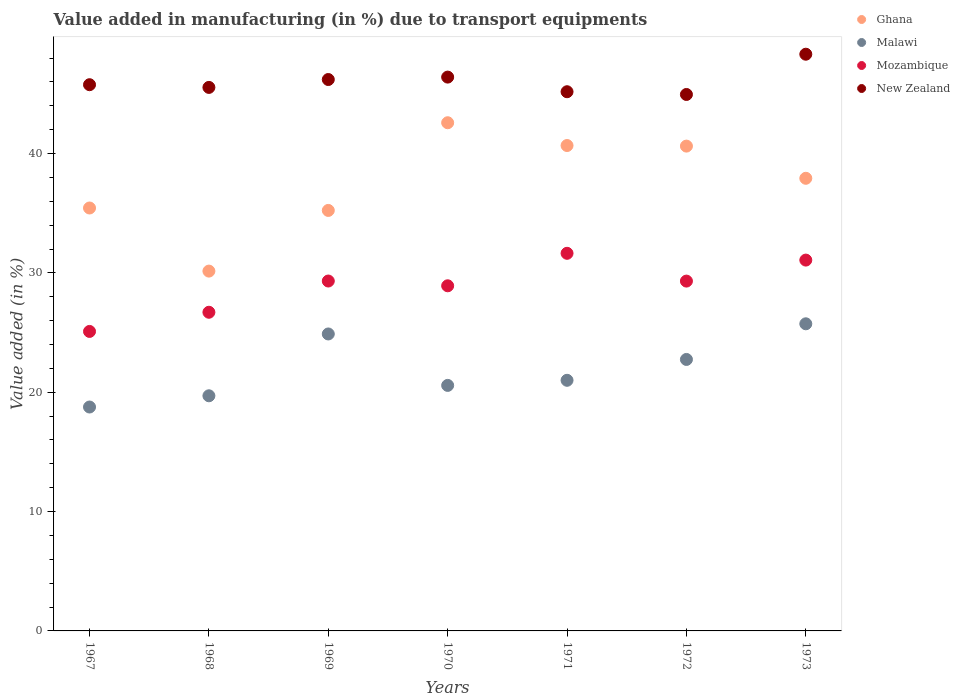How many different coloured dotlines are there?
Provide a succinct answer. 4. What is the percentage of value added in manufacturing due to transport equipments in Ghana in 1969?
Make the answer very short. 35.23. Across all years, what is the maximum percentage of value added in manufacturing due to transport equipments in Ghana?
Give a very brief answer. 42.58. Across all years, what is the minimum percentage of value added in manufacturing due to transport equipments in Mozambique?
Your answer should be very brief. 25.09. In which year was the percentage of value added in manufacturing due to transport equipments in Mozambique maximum?
Your answer should be very brief. 1971. In which year was the percentage of value added in manufacturing due to transport equipments in Ghana minimum?
Your response must be concise. 1968. What is the total percentage of value added in manufacturing due to transport equipments in Malawi in the graph?
Give a very brief answer. 153.4. What is the difference between the percentage of value added in manufacturing due to transport equipments in Mozambique in 1967 and that in 1972?
Offer a terse response. -4.22. What is the difference between the percentage of value added in manufacturing due to transport equipments in Mozambique in 1971 and the percentage of value added in manufacturing due to transport equipments in Malawi in 1967?
Keep it short and to the point. 12.88. What is the average percentage of value added in manufacturing due to transport equipments in Malawi per year?
Provide a short and direct response. 21.91. In the year 1968, what is the difference between the percentage of value added in manufacturing due to transport equipments in Ghana and percentage of value added in manufacturing due to transport equipments in New Zealand?
Provide a succinct answer. -15.39. What is the ratio of the percentage of value added in manufacturing due to transport equipments in New Zealand in 1968 to that in 1969?
Provide a succinct answer. 0.99. Is the percentage of value added in manufacturing due to transport equipments in Malawi in 1967 less than that in 1972?
Offer a terse response. Yes. Is the difference between the percentage of value added in manufacturing due to transport equipments in Ghana in 1969 and 1970 greater than the difference between the percentage of value added in manufacturing due to transport equipments in New Zealand in 1969 and 1970?
Offer a very short reply. No. What is the difference between the highest and the second highest percentage of value added in manufacturing due to transport equipments in Malawi?
Offer a terse response. 0.85. What is the difference between the highest and the lowest percentage of value added in manufacturing due to transport equipments in New Zealand?
Give a very brief answer. 3.37. In how many years, is the percentage of value added in manufacturing due to transport equipments in Ghana greater than the average percentage of value added in manufacturing due to transport equipments in Ghana taken over all years?
Your answer should be compact. 4. Is the sum of the percentage of value added in manufacturing due to transport equipments in Malawi in 1969 and 1971 greater than the maximum percentage of value added in manufacturing due to transport equipments in Mozambique across all years?
Your response must be concise. Yes. Does the percentage of value added in manufacturing due to transport equipments in Mozambique monotonically increase over the years?
Make the answer very short. No. Is the percentage of value added in manufacturing due to transport equipments in Ghana strictly less than the percentage of value added in manufacturing due to transport equipments in Mozambique over the years?
Offer a very short reply. No. Does the graph contain any zero values?
Make the answer very short. No. How many legend labels are there?
Your response must be concise. 4. What is the title of the graph?
Offer a very short reply. Value added in manufacturing (in %) due to transport equipments. Does "High income: OECD" appear as one of the legend labels in the graph?
Offer a terse response. No. What is the label or title of the X-axis?
Offer a very short reply. Years. What is the label or title of the Y-axis?
Ensure brevity in your answer.  Value added (in %). What is the Value added (in %) in Ghana in 1967?
Make the answer very short. 35.44. What is the Value added (in %) in Malawi in 1967?
Your answer should be very brief. 18.76. What is the Value added (in %) in Mozambique in 1967?
Ensure brevity in your answer.  25.09. What is the Value added (in %) in New Zealand in 1967?
Make the answer very short. 45.77. What is the Value added (in %) of Ghana in 1968?
Provide a short and direct response. 30.15. What is the Value added (in %) of Malawi in 1968?
Ensure brevity in your answer.  19.7. What is the Value added (in %) of Mozambique in 1968?
Your response must be concise. 26.7. What is the Value added (in %) in New Zealand in 1968?
Provide a succinct answer. 45.54. What is the Value added (in %) of Ghana in 1969?
Your answer should be very brief. 35.23. What is the Value added (in %) in Malawi in 1969?
Ensure brevity in your answer.  24.88. What is the Value added (in %) in Mozambique in 1969?
Offer a terse response. 29.32. What is the Value added (in %) in New Zealand in 1969?
Your response must be concise. 46.2. What is the Value added (in %) in Ghana in 1970?
Provide a succinct answer. 42.58. What is the Value added (in %) in Malawi in 1970?
Your response must be concise. 20.57. What is the Value added (in %) in Mozambique in 1970?
Offer a terse response. 28.92. What is the Value added (in %) in New Zealand in 1970?
Offer a very short reply. 46.4. What is the Value added (in %) in Ghana in 1971?
Your answer should be compact. 40.67. What is the Value added (in %) of Malawi in 1971?
Give a very brief answer. 21. What is the Value added (in %) of Mozambique in 1971?
Provide a short and direct response. 31.64. What is the Value added (in %) in New Zealand in 1971?
Offer a very short reply. 45.18. What is the Value added (in %) of Ghana in 1972?
Your answer should be very brief. 40.62. What is the Value added (in %) in Malawi in 1972?
Your answer should be compact. 22.75. What is the Value added (in %) of Mozambique in 1972?
Your response must be concise. 29.31. What is the Value added (in %) in New Zealand in 1972?
Give a very brief answer. 44.95. What is the Value added (in %) in Ghana in 1973?
Give a very brief answer. 37.93. What is the Value added (in %) in Malawi in 1973?
Your answer should be compact. 25.73. What is the Value added (in %) of Mozambique in 1973?
Give a very brief answer. 31.07. What is the Value added (in %) in New Zealand in 1973?
Provide a short and direct response. 48.32. Across all years, what is the maximum Value added (in %) in Ghana?
Your answer should be compact. 42.58. Across all years, what is the maximum Value added (in %) in Malawi?
Make the answer very short. 25.73. Across all years, what is the maximum Value added (in %) in Mozambique?
Your answer should be compact. 31.64. Across all years, what is the maximum Value added (in %) in New Zealand?
Ensure brevity in your answer.  48.32. Across all years, what is the minimum Value added (in %) in Ghana?
Your response must be concise. 30.15. Across all years, what is the minimum Value added (in %) of Malawi?
Offer a terse response. 18.76. Across all years, what is the minimum Value added (in %) of Mozambique?
Your answer should be compact. 25.09. Across all years, what is the minimum Value added (in %) of New Zealand?
Your answer should be compact. 44.95. What is the total Value added (in %) in Ghana in the graph?
Keep it short and to the point. 262.62. What is the total Value added (in %) in Malawi in the graph?
Keep it short and to the point. 153.4. What is the total Value added (in %) of Mozambique in the graph?
Make the answer very short. 202.06. What is the total Value added (in %) of New Zealand in the graph?
Offer a very short reply. 322.37. What is the difference between the Value added (in %) of Ghana in 1967 and that in 1968?
Provide a short and direct response. 5.29. What is the difference between the Value added (in %) in Malawi in 1967 and that in 1968?
Keep it short and to the point. -0.94. What is the difference between the Value added (in %) of Mozambique in 1967 and that in 1968?
Give a very brief answer. -1.61. What is the difference between the Value added (in %) of New Zealand in 1967 and that in 1968?
Provide a short and direct response. 0.23. What is the difference between the Value added (in %) in Ghana in 1967 and that in 1969?
Make the answer very short. 0.2. What is the difference between the Value added (in %) of Malawi in 1967 and that in 1969?
Provide a succinct answer. -6.12. What is the difference between the Value added (in %) of Mozambique in 1967 and that in 1969?
Your response must be concise. -4.22. What is the difference between the Value added (in %) in New Zealand in 1967 and that in 1969?
Ensure brevity in your answer.  -0.43. What is the difference between the Value added (in %) of Ghana in 1967 and that in 1970?
Give a very brief answer. -7.14. What is the difference between the Value added (in %) in Malawi in 1967 and that in 1970?
Keep it short and to the point. -1.81. What is the difference between the Value added (in %) of Mozambique in 1967 and that in 1970?
Provide a short and direct response. -3.82. What is the difference between the Value added (in %) of New Zealand in 1967 and that in 1970?
Keep it short and to the point. -0.64. What is the difference between the Value added (in %) of Ghana in 1967 and that in 1971?
Your response must be concise. -5.24. What is the difference between the Value added (in %) of Malawi in 1967 and that in 1971?
Your answer should be compact. -2.24. What is the difference between the Value added (in %) of Mozambique in 1967 and that in 1971?
Offer a terse response. -6.55. What is the difference between the Value added (in %) of New Zealand in 1967 and that in 1971?
Keep it short and to the point. 0.59. What is the difference between the Value added (in %) of Ghana in 1967 and that in 1972?
Make the answer very short. -5.19. What is the difference between the Value added (in %) of Malawi in 1967 and that in 1972?
Your answer should be compact. -3.99. What is the difference between the Value added (in %) in Mozambique in 1967 and that in 1972?
Give a very brief answer. -4.22. What is the difference between the Value added (in %) in New Zealand in 1967 and that in 1972?
Give a very brief answer. 0.82. What is the difference between the Value added (in %) in Ghana in 1967 and that in 1973?
Your answer should be very brief. -2.49. What is the difference between the Value added (in %) of Malawi in 1967 and that in 1973?
Your response must be concise. -6.97. What is the difference between the Value added (in %) in Mozambique in 1967 and that in 1973?
Offer a very short reply. -5.98. What is the difference between the Value added (in %) of New Zealand in 1967 and that in 1973?
Offer a terse response. -2.55. What is the difference between the Value added (in %) of Ghana in 1968 and that in 1969?
Provide a short and direct response. -5.08. What is the difference between the Value added (in %) in Malawi in 1968 and that in 1969?
Give a very brief answer. -5.18. What is the difference between the Value added (in %) in Mozambique in 1968 and that in 1969?
Keep it short and to the point. -2.62. What is the difference between the Value added (in %) in New Zealand in 1968 and that in 1969?
Offer a terse response. -0.66. What is the difference between the Value added (in %) in Ghana in 1968 and that in 1970?
Give a very brief answer. -12.43. What is the difference between the Value added (in %) of Malawi in 1968 and that in 1970?
Offer a very short reply. -0.87. What is the difference between the Value added (in %) in Mozambique in 1968 and that in 1970?
Your response must be concise. -2.22. What is the difference between the Value added (in %) of New Zealand in 1968 and that in 1970?
Ensure brevity in your answer.  -0.86. What is the difference between the Value added (in %) in Ghana in 1968 and that in 1971?
Ensure brevity in your answer.  -10.52. What is the difference between the Value added (in %) of Malawi in 1968 and that in 1971?
Your answer should be very brief. -1.3. What is the difference between the Value added (in %) of Mozambique in 1968 and that in 1971?
Give a very brief answer. -4.94. What is the difference between the Value added (in %) of New Zealand in 1968 and that in 1971?
Offer a very short reply. 0.36. What is the difference between the Value added (in %) of Ghana in 1968 and that in 1972?
Provide a succinct answer. -10.47. What is the difference between the Value added (in %) of Malawi in 1968 and that in 1972?
Your answer should be very brief. -3.04. What is the difference between the Value added (in %) of Mozambique in 1968 and that in 1972?
Your answer should be compact. -2.61. What is the difference between the Value added (in %) in New Zealand in 1968 and that in 1972?
Your answer should be very brief. 0.59. What is the difference between the Value added (in %) of Ghana in 1968 and that in 1973?
Provide a short and direct response. -7.78. What is the difference between the Value added (in %) of Malawi in 1968 and that in 1973?
Make the answer very short. -6.03. What is the difference between the Value added (in %) of Mozambique in 1968 and that in 1973?
Offer a very short reply. -4.37. What is the difference between the Value added (in %) in New Zealand in 1968 and that in 1973?
Provide a succinct answer. -2.78. What is the difference between the Value added (in %) in Ghana in 1969 and that in 1970?
Offer a terse response. -7.35. What is the difference between the Value added (in %) of Malawi in 1969 and that in 1970?
Your response must be concise. 4.31. What is the difference between the Value added (in %) of Mozambique in 1969 and that in 1970?
Keep it short and to the point. 0.4. What is the difference between the Value added (in %) in New Zealand in 1969 and that in 1970?
Provide a short and direct response. -0.2. What is the difference between the Value added (in %) of Ghana in 1969 and that in 1971?
Give a very brief answer. -5.44. What is the difference between the Value added (in %) of Malawi in 1969 and that in 1971?
Provide a short and direct response. 3.88. What is the difference between the Value added (in %) of Mozambique in 1969 and that in 1971?
Give a very brief answer. -2.32. What is the difference between the Value added (in %) of New Zealand in 1969 and that in 1971?
Your answer should be very brief. 1.02. What is the difference between the Value added (in %) of Ghana in 1969 and that in 1972?
Provide a succinct answer. -5.39. What is the difference between the Value added (in %) in Malawi in 1969 and that in 1972?
Provide a short and direct response. 2.14. What is the difference between the Value added (in %) in Mozambique in 1969 and that in 1972?
Ensure brevity in your answer.  0.01. What is the difference between the Value added (in %) of New Zealand in 1969 and that in 1972?
Provide a succinct answer. 1.25. What is the difference between the Value added (in %) of Ghana in 1969 and that in 1973?
Your answer should be compact. -2.69. What is the difference between the Value added (in %) of Malawi in 1969 and that in 1973?
Your answer should be very brief. -0.85. What is the difference between the Value added (in %) of Mozambique in 1969 and that in 1973?
Your answer should be compact. -1.75. What is the difference between the Value added (in %) in New Zealand in 1969 and that in 1973?
Provide a succinct answer. -2.12. What is the difference between the Value added (in %) in Ghana in 1970 and that in 1971?
Provide a succinct answer. 1.91. What is the difference between the Value added (in %) of Malawi in 1970 and that in 1971?
Your answer should be compact. -0.43. What is the difference between the Value added (in %) of Mozambique in 1970 and that in 1971?
Your response must be concise. -2.72. What is the difference between the Value added (in %) in New Zealand in 1970 and that in 1971?
Your answer should be very brief. 1.23. What is the difference between the Value added (in %) of Ghana in 1970 and that in 1972?
Your response must be concise. 1.96. What is the difference between the Value added (in %) of Malawi in 1970 and that in 1972?
Give a very brief answer. -2.17. What is the difference between the Value added (in %) in Mozambique in 1970 and that in 1972?
Ensure brevity in your answer.  -0.39. What is the difference between the Value added (in %) in New Zealand in 1970 and that in 1972?
Make the answer very short. 1.46. What is the difference between the Value added (in %) in Ghana in 1970 and that in 1973?
Give a very brief answer. 4.65. What is the difference between the Value added (in %) in Malawi in 1970 and that in 1973?
Ensure brevity in your answer.  -5.16. What is the difference between the Value added (in %) in Mozambique in 1970 and that in 1973?
Ensure brevity in your answer.  -2.15. What is the difference between the Value added (in %) of New Zealand in 1970 and that in 1973?
Your answer should be compact. -1.92. What is the difference between the Value added (in %) in Ghana in 1971 and that in 1972?
Give a very brief answer. 0.05. What is the difference between the Value added (in %) in Malawi in 1971 and that in 1972?
Offer a very short reply. -1.75. What is the difference between the Value added (in %) of Mozambique in 1971 and that in 1972?
Provide a succinct answer. 2.33. What is the difference between the Value added (in %) of New Zealand in 1971 and that in 1972?
Offer a very short reply. 0.23. What is the difference between the Value added (in %) in Ghana in 1971 and that in 1973?
Give a very brief answer. 2.75. What is the difference between the Value added (in %) of Malawi in 1971 and that in 1973?
Offer a terse response. -4.73. What is the difference between the Value added (in %) in Mozambique in 1971 and that in 1973?
Keep it short and to the point. 0.57. What is the difference between the Value added (in %) of New Zealand in 1971 and that in 1973?
Provide a succinct answer. -3.14. What is the difference between the Value added (in %) in Ghana in 1972 and that in 1973?
Make the answer very short. 2.7. What is the difference between the Value added (in %) in Malawi in 1972 and that in 1973?
Make the answer very short. -2.99. What is the difference between the Value added (in %) of Mozambique in 1972 and that in 1973?
Provide a short and direct response. -1.76. What is the difference between the Value added (in %) of New Zealand in 1972 and that in 1973?
Give a very brief answer. -3.37. What is the difference between the Value added (in %) of Ghana in 1967 and the Value added (in %) of Malawi in 1968?
Give a very brief answer. 15.73. What is the difference between the Value added (in %) of Ghana in 1967 and the Value added (in %) of Mozambique in 1968?
Keep it short and to the point. 8.74. What is the difference between the Value added (in %) in Ghana in 1967 and the Value added (in %) in New Zealand in 1968?
Ensure brevity in your answer.  -10.1. What is the difference between the Value added (in %) of Malawi in 1967 and the Value added (in %) of Mozambique in 1968?
Offer a very short reply. -7.94. What is the difference between the Value added (in %) in Malawi in 1967 and the Value added (in %) in New Zealand in 1968?
Keep it short and to the point. -26.78. What is the difference between the Value added (in %) of Mozambique in 1967 and the Value added (in %) of New Zealand in 1968?
Keep it short and to the point. -20.45. What is the difference between the Value added (in %) in Ghana in 1967 and the Value added (in %) in Malawi in 1969?
Make the answer very short. 10.55. What is the difference between the Value added (in %) of Ghana in 1967 and the Value added (in %) of Mozambique in 1969?
Make the answer very short. 6.12. What is the difference between the Value added (in %) of Ghana in 1967 and the Value added (in %) of New Zealand in 1969?
Offer a very short reply. -10.77. What is the difference between the Value added (in %) of Malawi in 1967 and the Value added (in %) of Mozambique in 1969?
Make the answer very short. -10.56. What is the difference between the Value added (in %) in Malawi in 1967 and the Value added (in %) in New Zealand in 1969?
Keep it short and to the point. -27.44. What is the difference between the Value added (in %) in Mozambique in 1967 and the Value added (in %) in New Zealand in 1969?
Offer a very short reply. -21.11. What is the difference between the Value added (in %) in Ghana in 1967 and the Value added (in %) in Malawi in 1970?
Provide a succinct answer. 14.86. What is the difference between the Value added (in %) in Ghana in 1967 and the Value added (in %) in Mozambique in 1970?
Offer a terse response. 6.52. What is the difference between the Value added (in %) in Ghana in 1967 and the Value added (in %) in New Zealand in 1970?
Offer a terse response. -10.97. What is the difference between the Value added (in %) in Malawi in 1967 and the Value added (in %) in Mozambique in 1970?
Offer a terse response. -10.16. What is the difference between the Value added (in %) of Malawi in 1967 and the Value added (in %) of New Zealand in 1970?
Offer a terse response. -27.64. What is the difference between the Value added (in %) in Mozambique in 1967 and the Value added (in %) in New Zealand in 1970?
Your response must be concise. -21.31. What is the difference between the Value added (in %) of Ghana in 1967 and the Value added (in %) of Malawi in 1971?
Provide a succinct answer. 14.44. What is the difference between the Value added (in %) of Ghana in 1967 and the Value added (in %) of Mozambique in 1971?
Give a very brief answer. 3.8. What is the difference between the Value added (in %) in Ghana in 1967 and the Value added (in %) in New Zealand in 1971?
Your answer should be very brief. -9.74. What is the difference between the Value added (in %) of Malawi in 1967 and the Value added (in %) of Mozambique in 1971?
Offer a terse response. -12.88. What is the difference between the Value added (in %) of Malawi in 1967 and the Value added (in %) of New Zealand in 1971?
Your answer should be very brief. -26.42. What is the difference between the Value added (in %) of Mozambique in 1967 and the Value added (in %) of New Zealand in 1971?
Keep it short and to the point. -20.08. What is the difference between the Value added (in %) of Ghana in 1967 and the Value added (in %) of Malawi in 1972?
Give a very brief answer. 12.69. What is the difference between the Value added (in %) in Ghana in 1967 and the Value added (in %) in Mozambique in 1972?
Offer a very short reply. 6.12. What is the difference between the Value added (in %) in Ghana in 1967 and the Value added (in %) in New Zealand in 1972?
Make the answer very short. -9.51. What is the difference between the Value added (in %) in Malawi in 1967 and the Value added (in %) in Mozambique in 1972?
Provide a short and direct response. -10.55. What is the difference between the Value added (in %) in Malawi in 1967 and the Value added (in %) in New Zealand in 1972?
Make the answer very short. -26.19. What is the difference between the Value added (in %) in Mozambique in 1967 and the Value added (in %) in New Zealand in 1972?
Provide a succinct answer. -19.86. What is the difference between the Value added (in %) in Ghana in 1967 and the Value added (in %) in Malawi in 1973?
Give a very brief answer. 9.7. What is the difference between the Value added (in %) in Ghana in 1967 and the Value added (in %) in Mozambique in 1973?
Offer a terse response. 4.36. What is the difference between the Value added (in %) in Ghana in 1967 and the Value added (in %) in New Zealand in 1973?
Give a very brief answer. -12.89. What is the difference between the Value added (in %) in Malawi in 1967 and the Value added (in %) in Mozambique in 1973?
Give a very brief answer. -12.31. What is the difference between the Value added (in %) in Malawi in 1967 and the Value added (in %) in New Zealand in 1973?
Ensure brevity in your answer.  -29.56. What is the difference between the Value added (in %) of Mozambique in 1967 and the Value added (in %) of New Zealand in 1973?
Your answer should be very brief. -23.23. What is the difference between the Value added (in %) in Ghana in 1968 and the Value added (in %) in Malawi in 1969?
Provide a succinct answer. 5.27. What is the difference between the Value added (in %) in Ghana in 1968 and the Value added (in %) in Mozambique in 1969?
Ensure brevity in your answer.  0.83. What is the difference between the Value added (in %) of Ghana in 1968 and the Value added (in %) of New Zealand in 1969?
Provide a succinct answer. -16.05. What is the difference between the Value added (in %) of Malawi in 1968 and the Value added (in %) of Mozambique in 1969?
Your answer should be very brief. -9.62. What is the difference between the Value added (in %) in Malawi in 1968 and the Value added (in %) in New Zealand in 1969?
Make the answer very short. -26.5. What is the difference between the Value added (in %) of Mozambique in 1968 and the Value added (in %) of New Zealand in 1969?
Offer a very short reply. -19.5. What is the difference between the Value added (in %) of Ghana in 1968 and the Value added (in %) of Malawi in 1970?
Ensure brevity in your answer.  9.58. What is the difference between the Value added (in %) in Ghana in 1968 and the Value added (in %) in Mozambique in 1970?
Keep it short and to the point. 1.23. What is the difference between the Value added (in %) of Ghana in 1968 and the Value added (in %) of New Zealand in 1970?
Make the answer very short. -16.26. What is the difference between the Value added (in %) in Malawi in 1968 and the Value added (in %) in Mozambique in 1970?
Offer a terse response. -9.22. What is the difference between the Value added (in %) of Malawi in 1968 and the Value added (in %) of New Zealand in 1970?
Your answer should be compact. -26.7. What is the difference between the Value added (in %) in Mozambique in 1968 and the Value added (in %) in New Zealand in 1970?
Give a very brief answer. -19.7. What is the difference between the Value added (in %) in Ghana in 1968 and the Value added (in %) in Malawi in 1971?
Provide a short and direct response. 9.15. What is the difference between the Value added (in %) of Ghana in 1968 and the Value added (in %) of Mozambique in 1971?
Provide a succinct answer. -1.49. What is the difference between the Value added (in %) in Ghana in 1968 and the Value added (in %) in New Zealand in 1971?
Your response must be concise. -15.03. What is the difference between the Value added (in %) in Malawi in 1968 and the Value added (in %) in Mozambique in 1971?
Give a very brief answer. -11.94. What is the difference between the Value added (in %) in Malawi in 1968 and the Value added (in %) in New Zealand in 1971?
Provide a succinct answer. -25.48. What is the difference between the Value added (in %) in Mozambique in 1968 and the Value added (in %) in New Zealand in 1971?
Your response must be concise. -18.48. What is the difference between the Value added (in %) in Ghana in 1968 and the Value added (in %) in Malawi in 1972?
Offer a very short reply. 7.4. What is the difference between the Value added (in %) of Ghana in 1968 and the Value added (in %) of Mozambique in 1972?
Provide a succinct answer. 0.84. What is the difference between the Value added (in %) in Ghana in 1968 and the Value added (in %) in New Zealand in 1972?
Give a very brief answer. -14.8. What is the difference between the Value added (in %) of Malawi in 1968 and the Value added (in %) of Mozambique in 1972?
Provide a short and direct response. -9.61. What is the difference between the Value added (in %) in Malawi in 1968 and the Value added (in %) in New Zealand in 1972?
Offer a very short reply. -25.25. What is the difference between the Value added (in %) in Mozambique in 1968 and the Value added (in %) in New Zealand in 1972?
Make the answer very short. -18.25. What is the difference between the Value added (in %) of Ghana in 1968 and the Value added (in %) of Malawi in 1973?
Ensure brevity in your answer.  4.42. What is the difference between the Value added (in %) in Ghana in 1968 and the Value added (in %) in Mozambique in 1973?
Provide a succinct answer. -0.92. What is the difference between the Value added (in %) of Ghana in 1968 and the Value added (in %) of New Zealand in 1973?
Ensure brevity in your answer.  -18.17. What is the difference between the Value added (in %) of Malawi in 1968 and the Value added (in %) of Mozambique in 1973?
Keep it short and to the point. -11.37. What is the difference between the Value added (in %) of Malawi in 1968 and the Value added (in %) of New Zealand in 1973?
Your response must be concise. -28.62. What is the difference between the Value added (in %) of Mozambique in 1968 and the Value added (in %) of New Zealand in 1973?
Your response must be concise. -21.62. What is the difference between the Value added (in %) in Ghana in 1969 and the Value added (in %) in Malawi in 1970?
Your answer should be compact. 14.66. What is the difference between the Value added (in %) in Ghana in 1969 and the Value added (in %) in Mozambique in 1970?
Give a very brief answer. 6.31. What is the difference between the Value added (in %) of Ghana in 1969 and the Value added (in %) of New Zealand in 1970?
Your response must be concise. -11.17. What is the difference between the Value added (in %) in Malawi in 1969 and the Value added (in %) in Mozambique in 1970?
Give a very brief answer. -4.04. What is the difference between the Value added (in %) in Malawi in 1969 and the Value added (in %) in New Zealand in 1970?
Make the answer very short. -21.52. What is the difference between the Value added (in %) of Mozambique in 1969 and the Value added (in %) of New Zealand in 1970?
Your answer should be compact. -17.09. What is the difference between the Value added (in %) in Ghana in 1969 and the Value added (in %) in Malawi in 1971?
Provide a short and direct response. 14.23. What is the difference between the Value added (in %) of Ghana in 1969 and the Value added (in %) of Mozambique in 1971?
Your answer should be compact. 3.59. What is the difference between the Value added (in %) in Ghana in 1969 and the Value added (in %) in New Zealand in 1971?
Offer a very short reply. -9.95. What is the difference between the Value added (in %) in Malawi in 1969 and the Value added (in %) in Mozambique in 1971?
Offer a very short reply. -6.76. What is the difference between the Value added (in %) in Malawi in 1969 and the Value added (in %) in New Zealand in 1971?
Ensure brevity in your answer.  -20.3. What is the difference between the Value added (in %) in Mozambique in 1969 and the Value added (in %) in New Zealand in 1971?
Keep it short and to the point. -15.86. What is the difference between the Value added (in %) of Ghana in 1969 and the Value added (in %) of Malawi in 1972?
Your answer should be compact. 12.49. What is the difference between the Value added (in %) in Ghana in 1969 and the Value added (in %) in Mozambique in 1972?
Your answer should be very brief. 5.92. What is the difference between the Value added (in %) in Ghana in 1969 and the Value added (in %) in New Zealand in 1972?
Offer a very short reply. -9.72. What is the difference between the Value added (in %) of Malawi in 1969 and the Value added (in %) of Mozambique in 1972?
Make the answer very short. -4.43. What is the difference between the Value added (in %) of Malawi in 1969 and the Value added (in %) of New Zealand in 1972?
Give a very brief answer. -20.07. What is the difference between the Value added (in %) in Mozambique in 1969 and the Value added (in %) in New Zealand in 1972?
Ensure brevity in your answer.  -15.63. What is the difference between the Value added (in %) in Ghana in 1969 and the Value added (in %) in Malawi in 1973?
Your answer should be very brief. 9.5. What is the difference between the Value added (in %) in Ghana in 1969 and the Value added (in %) in Mozambique in 1973?
Provide a succinct answer. 4.16. What is the difference between the Value added (in %) in Ghana in 1969 and the Value added (in %) in New Zealand in 1973?
Your response must be concise. -13.09. What is the difference between the Value added (in %) of Malawi in 1969 and the Value added (in %) of Mozambique in 1973?
Provide a succinct answer. -6.19. What is the difference between the Value added (in %) in Malawi in 1969 and the Value added (in %) in New Zealand in 1973?
Ensure brevity in your answer.  -23.44. What is the difference between the Value added (in %) in Mozambique in 1969 and the Value added (in %) in New Zealand in 1973?
Offer a very short reply. -19. What is the difference between the Value added (in %) of Ghana in 1970 and the Value added (in %) of Malawi in 1971?
Ensure brevity in your answer.  21.58. What is the difference between the Value added (in %) in Ghana in 1970 and the Value added (in %) in Mozambique in 1971?
Offer a very short reply. 10.94. What is the difference between the Value added (in %) in Ghana in 1970 and the Value added (in %) in New Zealand in 1971?
Your response must be concise. -2.6. What is the difference between the Value added (in %) in Malawi in 1970 and the Value added (in %) in Mozambique in 1971?
Keep it short and to the point. -11.07. What is the difference between the Value added (in %) in Malawi in 1970 and the Value added (in %) in New Zealand in 1971?
Offer a terse response. -24.61. What is the difference between the Value added (in %) of Mozambique in 1970 and the Value added (in %) of New Zealand in 1971?
Offer a very short reply. -16.26. What is the difference between the Value added (in %) in Ghana in 1970 and the Value added (in %) in Malawi in 1972?
Offer a terse response. 19.83. What is the difference between the Value added (in %) of Ghana in 1970 and the Value added (in %) of Mozambique in 1972?
Give a very brief answer. 13.27. What is the difference between the Value added (in %) of Ghana in 1970 and the Value added (in %) of New Zealand in 1972?
Offer a terse response. -2.37. What is the difference between the Value added (in %) of Malawi in 1970 and the Value added (in %) of Mozambique in 1972?
Give a very brief answer. -8.74. What is the difference between the Value added (in %) of Malawi in 1970 and the Value added (in %) of New Zealand in 1972?
Give a very brief answer. -24.38. What is the difference between the Value added (in %) in Mozambique in 1970 and the Value added (in %) in New Zealand in 1972?
Give a very brief answer. -16.03. What is the difference between the Value added (in %) in Ghana in 1970 and the Value added (in %) in Malawi in 1973?
Offer a terse response. 16.85. What is the difference between the Value added (in %) in Ghana in 1970 and the Value added (in %) in Mozambique in 1973?
Offer a very short reply. 11.51. What is the difference between the Value added (in %) in Ghana in 1970 and the Value added (in %) in New Zealand in 1973?
Make the answer very short. -5.74. What is the difference between the Value added (in %) of Malawi in 1970 and the Value added (in %) of Mozambique in 1973?
Ensure brevity in your answer.  -10.5. What is the difference between the Value added (in %) of Malawi in 1970 and the Value added (in %) of New Zealand in 1973?
Your answer should be very brief. -27.75. What is the difference between the Value added (in %) of Mozambique in 1970 and the Value added (in %) of New Zealand in 1973?
Your answer should be compact. -19.4. What is the difference between the Value added (in %) of Ghana in 1971 and the Value added (in %) of Malawi in 1972?
Ensure brevity in your answer.  17.93. What is the difference between the Value added (in %) in Ghana in 1971 and the Value added (in %) in Mozambique in 1972?
Offer a very short reply. 11.36. What is the difference between the Value added (in %) in Ghana in 1971 and the Value added (in %) in New Zealand in 1972?
Your answer should be compact. -4.28. What is the difference between the Value added (in %) in Malawi in 1971 and the Value added (in %) in Mozambique in 1972?
Give a very brief answer. -8.31. What is the difference between the Value added (in %) of Malawi in 1971 and the Value added (in %) of New Zealand in 1972?
Offer a terse response. -23.95. What is the difference between the Value added (in %) of Mozambique in 1971 and the Value added (in %) of New Zealand in 1972?
Ensure brevity in your answer.  -13.31. What is the difference between the Value added (in %) of Ghana in 1971 and the Value added (in %) of Malawi in 1973?
Offer a terse response. 14.94. What is the difference between the Value added (in %) of Ghana in 1971 and the Value added (in %) of New Zealand in 1973?
Provide a succinct answer. -7.65. What is the difference between the Value added (in %) in Malawi in 1971 and the Value added (in %) in Mozambique in 1973?
Your answer should be very brief. -10.07. What is the difference between the Value added (in %) of Malawi in 1971 and the Value added (in %) of New Zealand in 1973?
Ensure brevity in your answer.  -27.32. What is the difference between the Value added (in %) of Mozambique in 1971 and the Value added (in %) of New Zealand in 1973?
Make the answer very short. -16.68. What is the difference between the Value added (in %) of Ghana in 1972 and the Value added (in %) of Malawi in 1973?
Offer a very short reply. 14.89. What is the difference between the Value added (in %) of Ghana in 1972 and the Value added (in %) of Mozambique in 1973?
Keep it short and to the point. 9.55. What is the difference between the Value added (in %) in Ghana in 1972 and the Value added (in %) in New Zealand in 1973?
Give a very brief answer. -7.7. What is the difference between the Value added (in %) in Malawi in 1972 and the Value added (in %) in Mozambique in 1973?
Your response must be concise. -8.33. What is the difference between the Value added (in %) of Malawi in 1972 and the Value added (in %) of New Zealand in 1973?
Offer a very short reply. -25.58. What is the difference between the Value added (in %) in Mozambique in 1972 and the Value added (in %) in New Zealand in 1973?
Provide a succinct answer. -19.01. What is the average Value added (in %) in Ghana per year?
Make the answer very short. 37.52. What is the average Value added (in %) in Malawi per year?
Make the answer very short. 21.91. What is the average Value added (in %) of Mozambique per year?
Ensure brevity in your answer.  28.87. What is the average Value added (in %) of New Zealand per year?
Ensure brevity in your answer.  46.05. In the year 1967, what is the difference between the Value added (in %) in Ghana and Value added (in %) in Malawi?
Provide a succinct answer. 16.68. In the year 1967, what is the difference between the Value added (in %) in Ghana and Value added (in %) in Mozambique?
Offer a very short reply. 10.34. In the year 1967, what is the difference between the Value added (in %) in Ghana and Value added (in %) in New Zealand?
Provide a succinct answer. -10.33. In the year 1967, what is the difference between the Value added (in %) in Malawi and Value added (in %) in Mozambique?
Your response must be concise. -6.33. In the year 1967, what is the difference between the Value added (in %) in Malawi and Value added (in %) in New Zealand?
Your answer should be compact. -27.01. In the year 1967, what is the difference between the Value added (in %) of Mozambique and Value added (in %) of New Zealand?
Your answer should be very brief. -20.67. In the year 1968, what is the difference between the Value added (in %) in Ghana and Value added (in %) in Malawi?
Keep it short and to the point. 10.45. In the year 1968, what is the difference between the Value added (in %) in Ghana and Value added (in %) in Mozambique?
Ensure brevity in your answer.  3.45. In the year 1968, what is the difference between the Value added (in %) of Ghana and Value added (in %) of New Zealand?
Provide a short and direct response. -15.39. In the year 1968, what is the difference between the Value added (in %) in Malawi and Value added (in %) in Mozambique?
Keep it short and to the point. -7. In the year 1968, what is the difference between the Value added (in %) in Malawi and Value added (in %) in New Zealand?
Offer a terse response. -25.84. In the year 1968, what is the difference between the Value added (in %) in Mozambique and Value added (in %) in New Zealand?
Keep it short and to the point. -18.84. In the year 1969, what is the difference between the Value added (in %) in Ghana and Value added (in %) in Malawi?
Keep it short and to the point. 10.35. In the year 1969, what is the difference between the Value added (in %) of Ghana and Value added (in %) of Mozambique?
Offer a very short reply. 5.91. In the year 1969, what is the difference between the Value added (in %) of Ghana and Value added (in %) of New Zealand?
Give a very brief answer. -10.97. In the year 1969, what is the difference between the Value added (in %) in Malawi and Value added (in %) in Mozambique?
Offer a terse response. -4.44. In the year 1969, what is the difference between the Value added (in %) in Malawi and Value added (in %) in New Zealand?
Provide a succinct answer. -21.32. In the year 1969, what is the difference between the Value added (in %) of Mozambique and Value added (in %) of New Zealand?
Your answer should be compact. -16.88. In the year 1970, what is the difference between the Value added (in %) in Ghana and Value added (in %) in Malawi?
Offer a terse response. 22.01. In the year 1970, what is the difference between the Value added (in %) of Ghana and Value added (in %) of Mozambique?
Your answer should be very brief. 13.66. In the year 1970, what is the difference between the Value added (in %) of Ghana and Value added (in %) of New Zealand?
Ensure brevity in your answer.  -3.82. In the year 1970, what is the difference between the Value added (in %) of Malawi and Value added (in %) of Mozambique?
Keep it short and to the point. -8.35. In the year 1970, what is the difference between the Value added (in %) of Malawi and Value added (in %) of New Zealand?
Keep it short and to the point. -25.83. In the year 1970, what is the difference between the Value added (in %) of Mozambique and Value added (in %) of New Zealand?
Your answer should be very brief. -17.49. In the year 1971, what is the difference between the Value added (in %) of Ghana and Value added (in %) of Malawi?
Provide a succinct answer. 19.67. In the year 1971, what is the difference between the Value added (in %) of Ghana and Value added (in %) of Mozambique?
Offer a very short reply. 9.03. In the year 1971, what is the difference between the Value added (in %) in Ghana and Value added (in %) in New Zealand?
Give a very brief answer. -4.51. In the year 1971, what is the difference between the Value added (in %) in Malawi and Value added (in %) in Mozambique?
Provide a succinct answer. -10.64. In the year 1971, what is the difference between the Value added (in %) of Malawi and Value added (in %) of New Zealand?
Your answer should be compact. -24.18. In the year 1971, what is the difference between the Value added (in %) of Mozambique and Value added (in %) of New Zealand?
Keep it short and to the point. -13.54. In the year 1972, what is the difference between the Value added (in %) in Ghana and Value added (in %) in Malawi?
Your answer should be very brief. 17.88. In the year 1972, what is the difference between the Value added (in %) in Ghana and Value added (in %) in Mozambique?
Give a very brief answer. 11.31. In the year 1972, what is the difference between the Value added (in %) in Ghana and Value added (in %) in New Zealand?
Make the answer very short. -4.33. In the year 1972, what is the difference between the Value added (in %) of Malawi and Value added (in %) of Mozambique?
Ensure brevity in your answer.  -6.57. In the year 1972, what is the difference between the Value added (in %) in Malawi and Value added (in %) in New Zealand?
Offer a terse response. -22.2. In the year 1972, what is the difference between the Value added (in %) in Mozambique and Value added (in %) in New Zealand?
Give a very brief answer. -15.64. In the year 1973, what is the difference between the Value added (in %) of Ghana and Value added (in %) of Malawi?
Offer a very short reply. 12.19. In the year 1973, what is the difference between the Value added (in %) of Ghana and Value added (in %) of Mozambique?
Offer a terse response. 6.85. In the year 1973, what is the difference between the Value added (in %) in Ghana and Value added (in %) in New Zealand?
Keep it short and to the point. -10.4. In the year 1973, what is the difference between the Value added (in %) of Malawi and Value added (in %) of Mozambique?
Provide a short and direct response. -5.34. In the year 1973, what is the difference between the Value added (in %) in Malawi and Value added (in %) in New Zealand?
Offer a terse response. -22.59. In the year 1973, what is the difference between the Value added (in %) of Mozambique and Value added (in %) of New Zealand?
Your response must be concise. -17.25. What is the ratio of the Value added (in %) of Ghana in 1967 to that in 1968?
Your response must be concise. 1.18. What is the ratio of the Value added (in %) in Malawi in 1967 to that in 1968?
Keep it short and to the point. 0.95. What is the ratio of the Value added (in %) in Mozambique in 1967 to that in 1968?
Keep it short and to the point. 0.94. What is the ratio of the Value added (in %) of Ghana in 1967 to that in 1969?
Provide a short and direct response. 1.01. What is the ratio of the Value added (in %) in Malawi in 1967 to that in 1969?
Your answer should be very brief. 0.75. What is the ratio of the Value added (in %) in Mozambique in 1967 to that in 1969?
Keep it short and to the point. 0.86. What is the ratio of the Value added (in %) in New Zealand in 1967 to that in 1969?
Ensure brevity in your answer.  0.99. What is the ratio of the Value added (in %) of Ghana in 1967 to that in 1970?
Your answer should be very brief. 0.83. What is the ratio of the Value added (in %) of Malawi in 1967 to that in 1970?
Offer a very short reply. 0.91. What is the ratio of the Value added (in %) in Mozambique in 1967 to that in 1970?
Offer a very short reply. 0.87. What is the ratio of the Value added (in %) in New Zealand in 1967 to that in 1970?
Offer a very short reply. 0.99. What is the ratio of the Value added (in %) of Ghana in 1967 to that in 1971?
Your answer should be compact. 0.87. What is the ratio of the Value added (in %) of Malawi in 1967 to that in 1971?
Your answer should be very brief. 0.89. What is the ratio of the Value added (in %) of Mozambique in 1967 to that in 1971?
Provide a succinct answer. 0.79. What is the ratio of the Value added (in %) in New Zealand in 1967 to that in 1971?
Keep it short and to the point. 1.01. What is the ratio of the Value added (in %) of Ghana in 1967 to that in 1972?
Offer a very short reply. 0.87. What is the ratio of the Value added (in %) of Malawi in 1967 to that in 1972?
Give a very brief answer. 0.82. What is the ratio of the Value added (in %) of Mozambique in 1967 to that in 1972?
Ensure brevity in your answer.  0.86. What is the ratio of the Value added (in %) in New Zealand in 1967 to that in 1972?
Your response must be concise. 1.02. What is the ratio of the Value added (in %) in Ghana in 1967 to that in 1973?
Offer a terse response. 0.93. What is the ratio of the Value added (in %) in Malawi in 1967 to that in 1973?
Offer a very short reply. 0.73. What is the ratio of the Value added (in %) in Mozambique in 1967 to that in 1973?
Make the answer very short. 0.81. What is the ratio of the Value added (in %) of New Zealand in 1967 to that in 1973?
Ensure brevity in your answer.  0.95. What is the ratio of the Value added (in %) of Ghana in 1968 to that in 1969?
Provide a short and direct response. 0.86. What is the ratio of the Value added (in %) of Malawi in 1968 to that in 1969?
Ensure brevity in your answer.  0.79. What is the ratio of the Value added (in %) in Mozambique in 1968 to that in 1969?
Ensure brevity in your answer.  0.91. What is the ratio of the Value added (in %) of New Zealand in 1968 to that in 1969?
Ensure brevity in your answer.  0.99. What is the ratio of the Value added (in %) of Ghana in 1968 to that in 1970?
Your answer should be compact. 0.71. What is the ratio of the Value added (in %) in Malawi in 1968 to that in 1970?
Offer a very short reply. 0.96. What is the ratio of the Value added (in %) of Mozambique in 1968 to that in 1970?
Keep it short and to the point. 0.92. What is the ratio of the Value added (in %) in New Zealand in 1968 to that in 1970?
Your response must be concise. 0.98. What is the ratio of the Value added (in %) in Ghana in 1968 to that in 1971?
Your answer should be very brief. 0.74. What is the ratio of the Value added (in %) of Malawi in 1968 to that in 1971?
Your answer should be compact. 0.94. What is the ratio of the Value added (in %) of Mozambique in 1968 to that in 1971?
Your response must be concise. 0.84. What is the ratio of the Value added (in %) in Ghana in 1968 to that in 1972?
Ensure brevity in your answer.  0.74. What is the ratio of the Value added (in %) in Malawi in 1968 to that in 1972?
Provide a succinct answer. 0.87. What is the ratio of the Value added (in %) in Mozambique in 1968 to that in 1972?
Your response must be concise. 0.91. What is the ratio of the Value added (in %) of New Zealand in 1968 to that in 1972?
Ensure brevity in your answer.  1.01. What is the ratio of the Value added (in %) in Ghana in 1968 to that in 1973?
Offer a terse response. 0.8. What is the ratio of the Value added (in %) in Malawi in 1968 to that in 1973?
Make the answer very short. 0.77. What is the ratio of the Value added (in %) in Mozambique in 1968 to that in 1973?
Offer a terse response. 0.86. What is the ratio of the Value added (in %) of New Zealand in 1968 to that in 1973?
Provide a succinct answer. 0.94. What is the ratio of the Value added (in %) in Ghana in 1969 to that in 1970?
Provide a succinct answer. 0.83. What is the ratio of the Value added (in %) of Malawi in 1969 to that in 1970?
Give a very brief answer. 1.21. What is the ratio of the Value added (in %) in Mozambique in 1969 to that in 1970?
Keep it short and to the point. 1.01. What is the ratio of the Value added (in %) in Ghana in 1969 to that in 1971?
Provide a succinct answer. 0.87. What is the ratio of the Value added (in %) of Malawi in 1969 to that in 1971?
Offer a very short reply. 1.18. What is the ratio of the Value added (in %) in Mozambique in 1969 to that in 1971?
Offer a very short reply. 0.93. What is the ratio of the Value added (in %) of New Zealand in 1969 to that in 1971?
Provide a succinct answer. 1.02. What is the ratio of the Value added (in %) of Ghana in 1969 to that in 1972?
Offer a very short reply. 0.87. What is the ratio of the Value added (in %) in Malawi in 1969 to that in 1972?
Provide a short and direct response. 1.09. What is the ratio of the Value added (in %) in Mozambique in 1969 to that in 1972?
Give a very brief answer. 1. What is the ratio of the Value added (in %) of New Zealand in 1969 to that in 1972?
Provide a succinct answer. 1.03. What is the ratio of the Value added (in %) of Ghana in 1969 to that in 1973?
Make the answer very short. 0.93. What is the ratio of the Value added (in %) of Malawi in 1969 to that in 1973?
Offer a terse response. 0.97. What is the ratio of the Value added (in %) of Mozambique in 1969 to that in 1973?
Your answer should be very brief. 0.94. What is the ratio of the Value added (in %) in New Zealand in 1969 to that in 1973?
Ensure brevity in your answer.  0.96. What is the ratio of the Value added (in %) in Ghana in 1970 to that in 1971?
Offer a terse response. 1.05. What is the ratio of the Value added (in %) in Malawi in 1970 to that in 1971?
Your answer should be compact. 0.98. What is the ratio of the Value added (in %) in Mozambique in 1970 to that in 1971?
Your answer should be compact. 0.91. What is the ratio of the Value added (in %) of New Zealand in 1970 to that in 1971?
Your response must be concise. 1.03. What is the ratio of the Value added (in %) of Ghana in 1970 to that in 1972?
Ensure brevity in your answer.  1.05. What is the ratio of the Value added (in %) of Malawi in 1970 to that in 1972?
Your response must be concise. 0.9. What is the ratio of the Value added (in %) in Mozambique in 1970 to that in 1972?
Your answer should be compact. 0.99. What is the ratio of the Value added (in %) in New Zealand in 1970 to that in 1972?
Ensure brevity in your answer.  1.03. What is the ratio of the Value added (in %) in Ghana in 1970 to that in 1973?
Provide a succinct answer. 1.12. What is the ratio of the Value added (in %) in Malawi in 1970 to that in 1973?
Your response must be concise. 0.8. What is the ratio of the Value added (in %) in Mozambique in 1970 to that in 1973?
Ensure brevity in your answer.  0.93. What is the ratio of the Value added (in %) of New Zealand in 1970 to that in 1973?
Keep it short and to the point. 0.96. What is the ratio of the Value added (in %) of Ghana in 1971 to that in 1972?
Make the answer very short. 1. What is the ratio of the Value added (in %) in Malawi in 1971 to that in 1972?
Your answer should be compact. 0.92. What is the ratio of the Value added (in %) of Mozambique in 1971 to that in 1972?
Offer a terse response. 1.08. What is the ratio of the Value added (in %) in New Zealand in 1971 to that in 1972?
Make the answer very short. 1.01. What is the ratio of the Value added (in %) in Ghana in 1971 to that in 1973?
Offer a very short reply. 1.07. What is the ratio of the Value added (in %) of Malawi in 1971 to that in 1973?
Provide a succinct answer. 0.82. What is the ratio of the Value added (in %) in Mozambique in 1971 to that in 1973?
Offer a terse response. 1.02. What is the ratio of the Value added (in %) of New Zealand in 1971 to that in 1973?
Your response must be concise. 0.93. What is the ratio of the Value added (in %) of Ghana in 1972 to that in 1973?
Ensure brevity in your answer.  1.07. What is the ratio of the Value added (in %) in Malawi in 1972 to that in 1973?
Offer a very short reply. 0.88. What is the ratio of the Value added (in %) of Mozambique in 1972 to that in 1973?
Ensure brevity in your answer.  0.94. What is the ratio of the Value added (in %) of New Zealand in 1972 to that in 1973?
Ensure brevity in your answer.  0.93. What is the difference between the highest and the second highest Value added (in %) in Ghana?
Offer a terse response. 1.91. What is the difference between the highest and the second highest Value added (in %) of Malawi?
Keep it short and to the point. 0.85. What is the difference between the highest and the second highest Value added (in %) in Mozambique?
Give a very brief answer. 0.57. What is the difference between the highest and the second highest Value added (in %) of New Zealand?
Your answer should be very brief. 1.92. What is the difference between the highest and the lowest Value added (in %) of Ghana?
Provide a succinct answer. 12.43. What is the difference between the highest and the lowest Value added (in %) of Malawi?
Provide a succinct answer. 6.97. What is the difference between the highest and the lowest Value added (in %) in Mozambique?
Make the answer very short. 6.55. What is the difference between the highest and the lowest Value added (in %) of New Zealand?
Offer a very short reply. 3.37. 